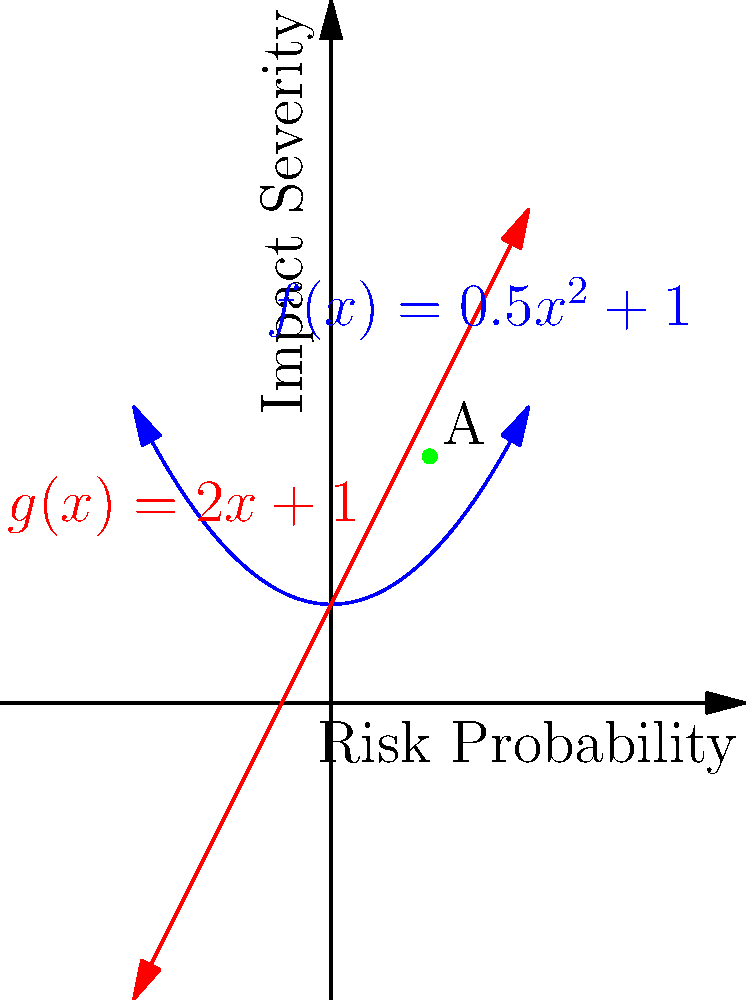The graph shows two risk assessment models for supply chain disruptions: a quadratic model $f(x) = 0.5x^2 + 1$ (blue) and a linear model $g(x) = 2x + 1$ (red). Point A represents a specific supply chain risk. Which model suggests a higher impact severity for this risk, and what does this imply for risk mitigation strategies? To determine which model suggests a higher impact severity for the risk at point A, we need to follow these steps:

1. Identify the x-coordinate (risk probability) of point A: x = 1

2. Calculate the y-coordinate (impact severity) using both models:
   For $f(x)$: $f(1) = 0.5(1)^2 + 1 = 1.5$
   For $g(x)$: $g(1) = 2(1) + 1 = 3$

3. Compare the results:
   $g(1) = 3 > f(1) = 1.5$

4. Interpret the results:
   The linear model $g(x)$ suggests a higher impact severity for the given risk probability.

5. Implications for risk mitigation strategies:
   - The linear model indicates a more aggressive risk assessment, suggesting that mitigation efforts should be prioritized for this risk.
   - The quadratic model suggests a lower impact, which might lead to a more moderate approach to risk mitigation.
   - In practice, the company should consider both models and potentially use a weighted average or more sophisticated combination to inform their risk mitigation strategy.
   - The discrepancy between models highlights the importance of using multiple risk assessment tools and continuously refining the models based on real-world data and outcomes.
Answer: Linear model; prioritize mitigation efforts 